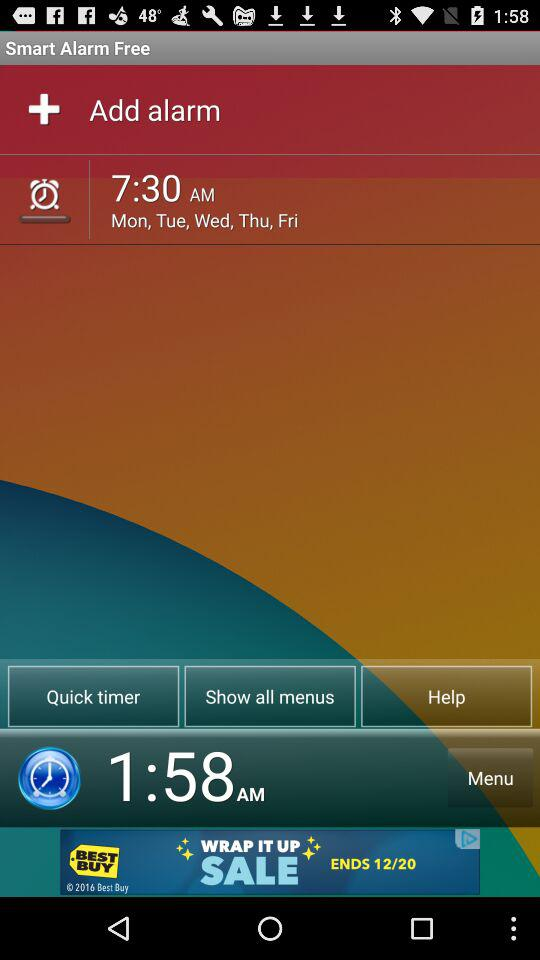How much are the savings during Best Buy's "WRAP IT UP" sale?
When the provided information is insufficient, respond with <no answer>. <no answer> 